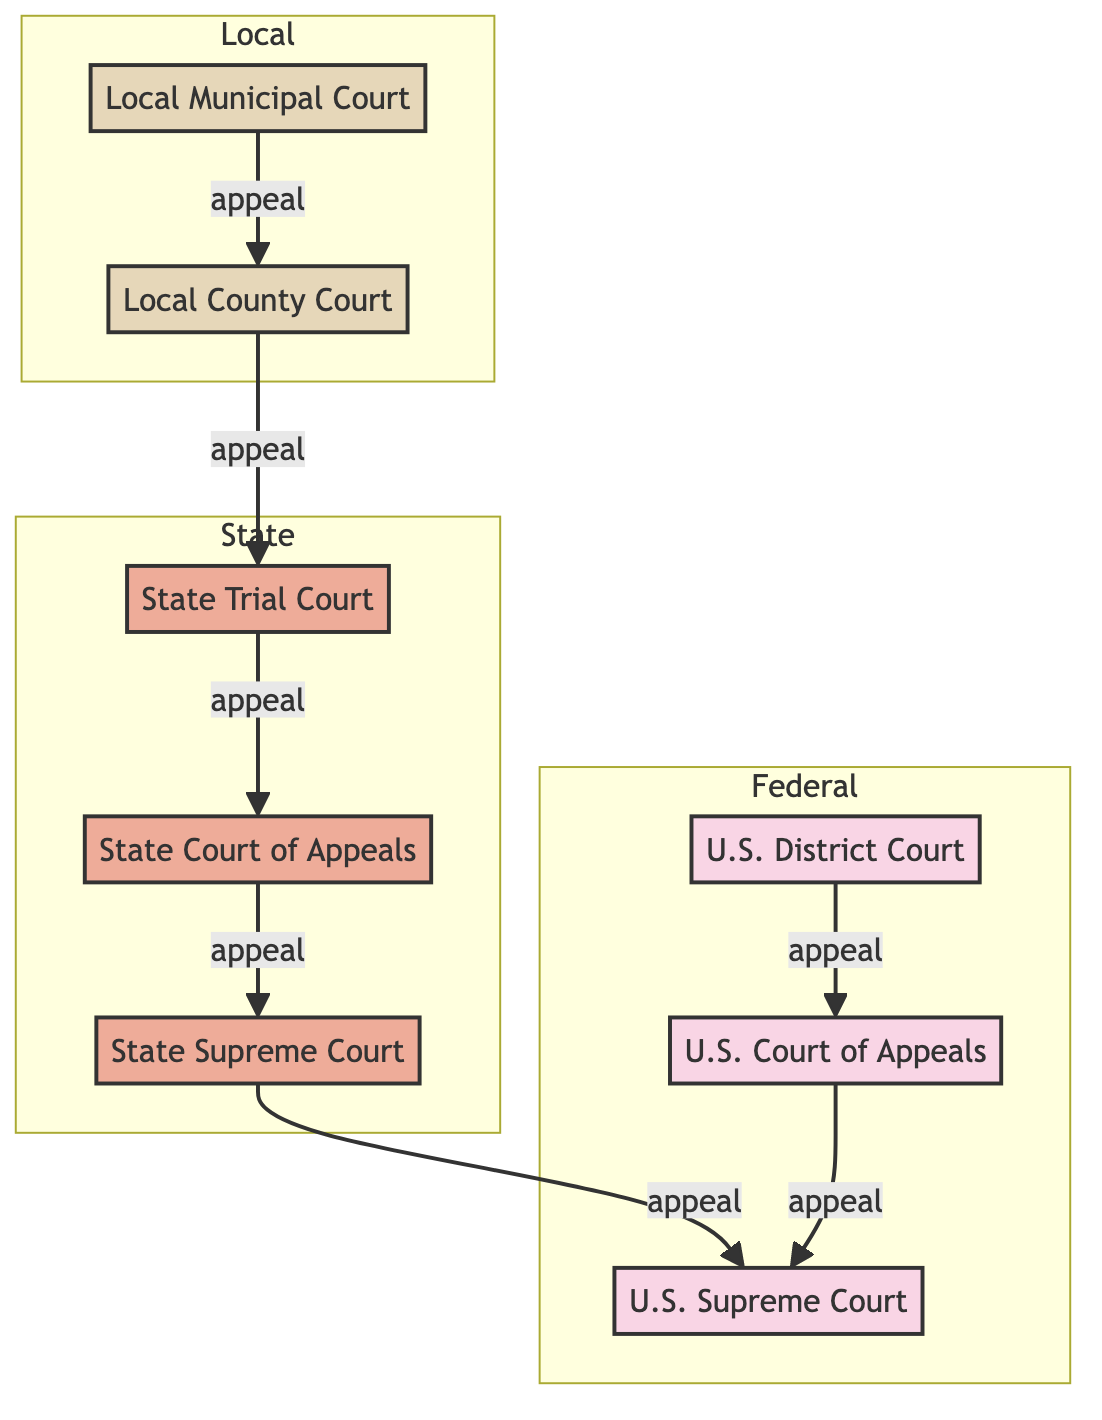What is the highest appellate court in the United States? The diagram identifies the U.S. Supreme Court as the highest appellate court, stated in its description at the top level of the Federal section.
Answer: U.S. Supreme Court How many local courts are depicted in the diagram? The diagram includes two local courts: Local Municipal Court and Local County Court, which can be counted from the Local section of the diagram.
Answer: 2 Which court handles municipal ordinance violations? The diagram indicates that the Local Municipal Court is responsible for handling municipal ordinance violations as described in its role.
Answer: Local Municipal Court What is the relationship between State Trial Court and State Court of Appeals? The diagram shows a directed edge from State Trial Court to State Court of Appeals labeled as "appeal," indicating that appeals from the trial court go to the appellate court.
Answer: appeal Which court comes after the State Court of Appeals in the appeal process? Following the directed edge from State Court of Appeals to State Supreme Court, labeled as "appeal," it indicates that the State Supreme Court is the next level after the State Court of Appeals for appeals.
Answer: State Supreme Court What level is the US District Court classified under? Referring to the diagram, the US District Court is positioned in the Federal section, clearly marked under the Federal level.
Answer: Federal How many courts can directly appeal to the US Supreme Court? By following the edges that lead directly into the US Supreme Court, there are two courts: State Supreme Court and US Court of Appeals that can appeal to it.
Answer: 2 Is there any local court that appeals directly to the State Trial Court? The diagram shows a direct appeal from Local County Court to State Trial Court, indicating that the Local County Court can appeal directly to the State Trial Court.
Answer: Yes Which court acts as the general trial courts in the state? The diagram specifies that the State Trial Court is designated as the general trial courts in the state, evident from its description within the State section.
Answer: State Trial Court 